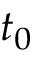Convert formula to latex. <formula><loc_0><loc_0><loc_500><loc_500>t _ { 0 }</formula> 